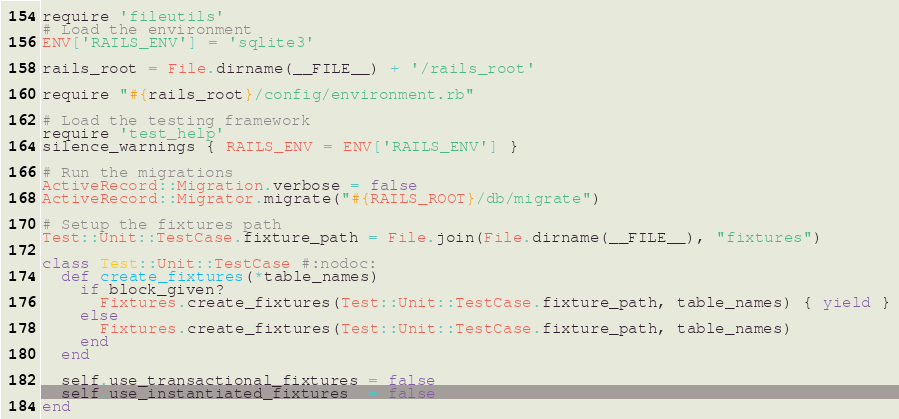<code> <loc_0><loc_0><loc_500><loc_500><_Ruby_>require 'fileutils'
# Load the environment
ENV['RAILS_ENV'] = 'sqlite3'

rails_root = File.dirname(__FILE__) + '/rails_root'

require "#{rails_root}/config/environment.rb"

# Load the testing framework
require 'test_help'
silence_warnings { RAILS_ENV = ENV['RAILS_ENV'] }

# Run the migrations
ActiveRecord::Migration.verbose = false
ActiveRecord::Migrator.migrate("#{RAILS_ROOT}/db/migrate")

# Setup the fixtures path
Test::Unit::TestCase.fixture_path = File.join(File.dirname(__FILE__), "fixtures")

class Test::Unit::TestCase #:nodoc:
  def create_fixtures(*table_names)
    if block_given?
      Fixtures.create_fixtures(Test::Unit::TestCase.fixture_path, table_names) { yield }
    else
      Fixtures.create_fixtures(Test::Unit::TestCase.fixture_path, table_names)
    end
  end

  self.use_transactional_fixtures = false
  self.use_instantiated_fixtures  = false
end</code> 